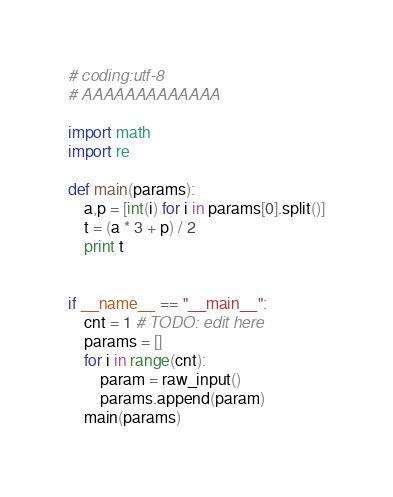Convert code to text. <code><loc_0><loc_0><loc_500><loc_500><_Python_># coding:utf-8
# AAAAAAAAAAAAA

import math
import re

def main(params):
    a,p = [int(i) for i in params[0].split()]
    t = (a * 3 + p) / 2
    print t


if __name__ == "__main__":
    cnt = 1 # TODO: edit here
    params = []
    for i in range(cnt):
        param = raw_input()
        params.append(param)
    main(params)

</code> 